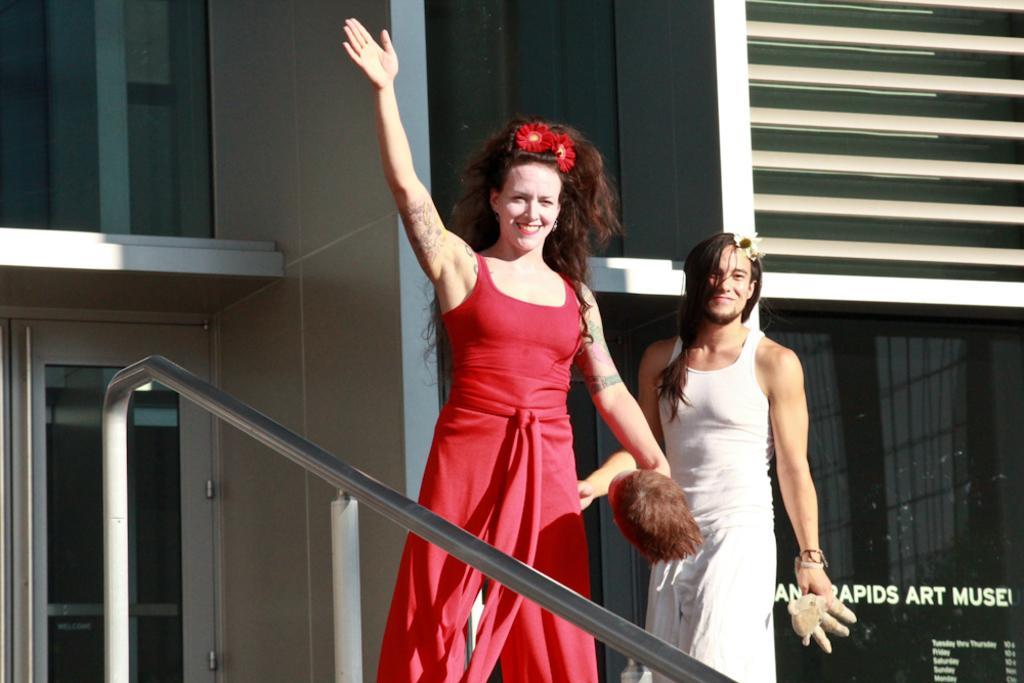How would you summarize this image in a sentence or two? In this image we can see two persons. They are holding something in the hand. In the back there is a building. On the building something is written. Also we can see a handle. 